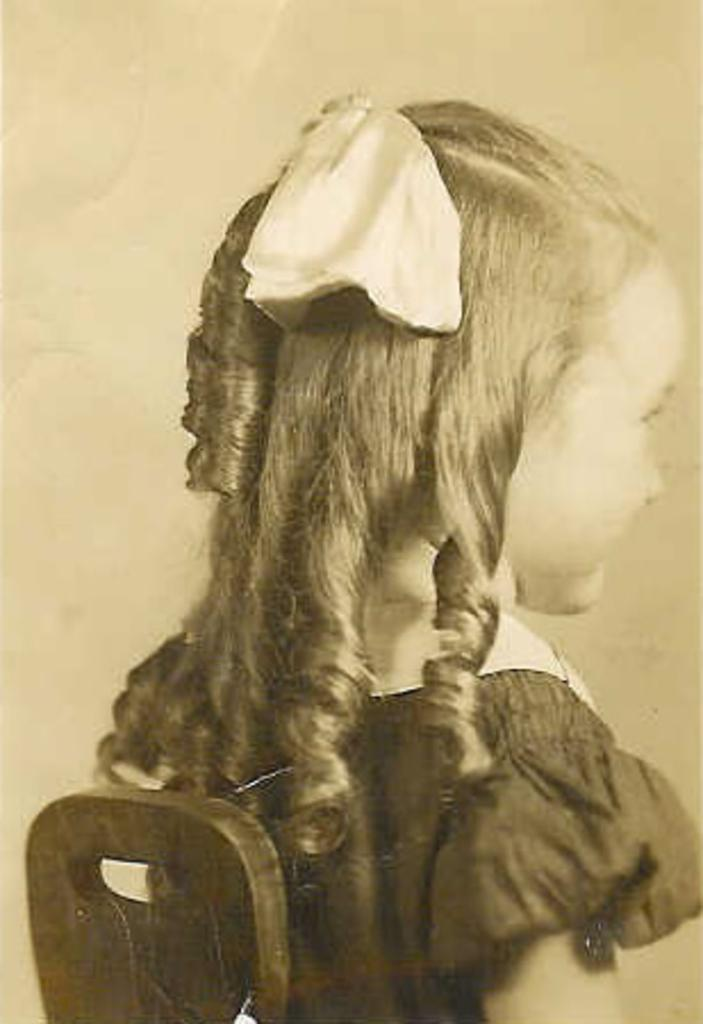What is the main subject of the image? The main subject of the image is a kid. Can you describe the kid's attire in the image? The kid is wearing clothes in the image. What type of steel is used to construct the trees in the image? There are no trees or steel present in the image; it features a kid wearing clothes. 